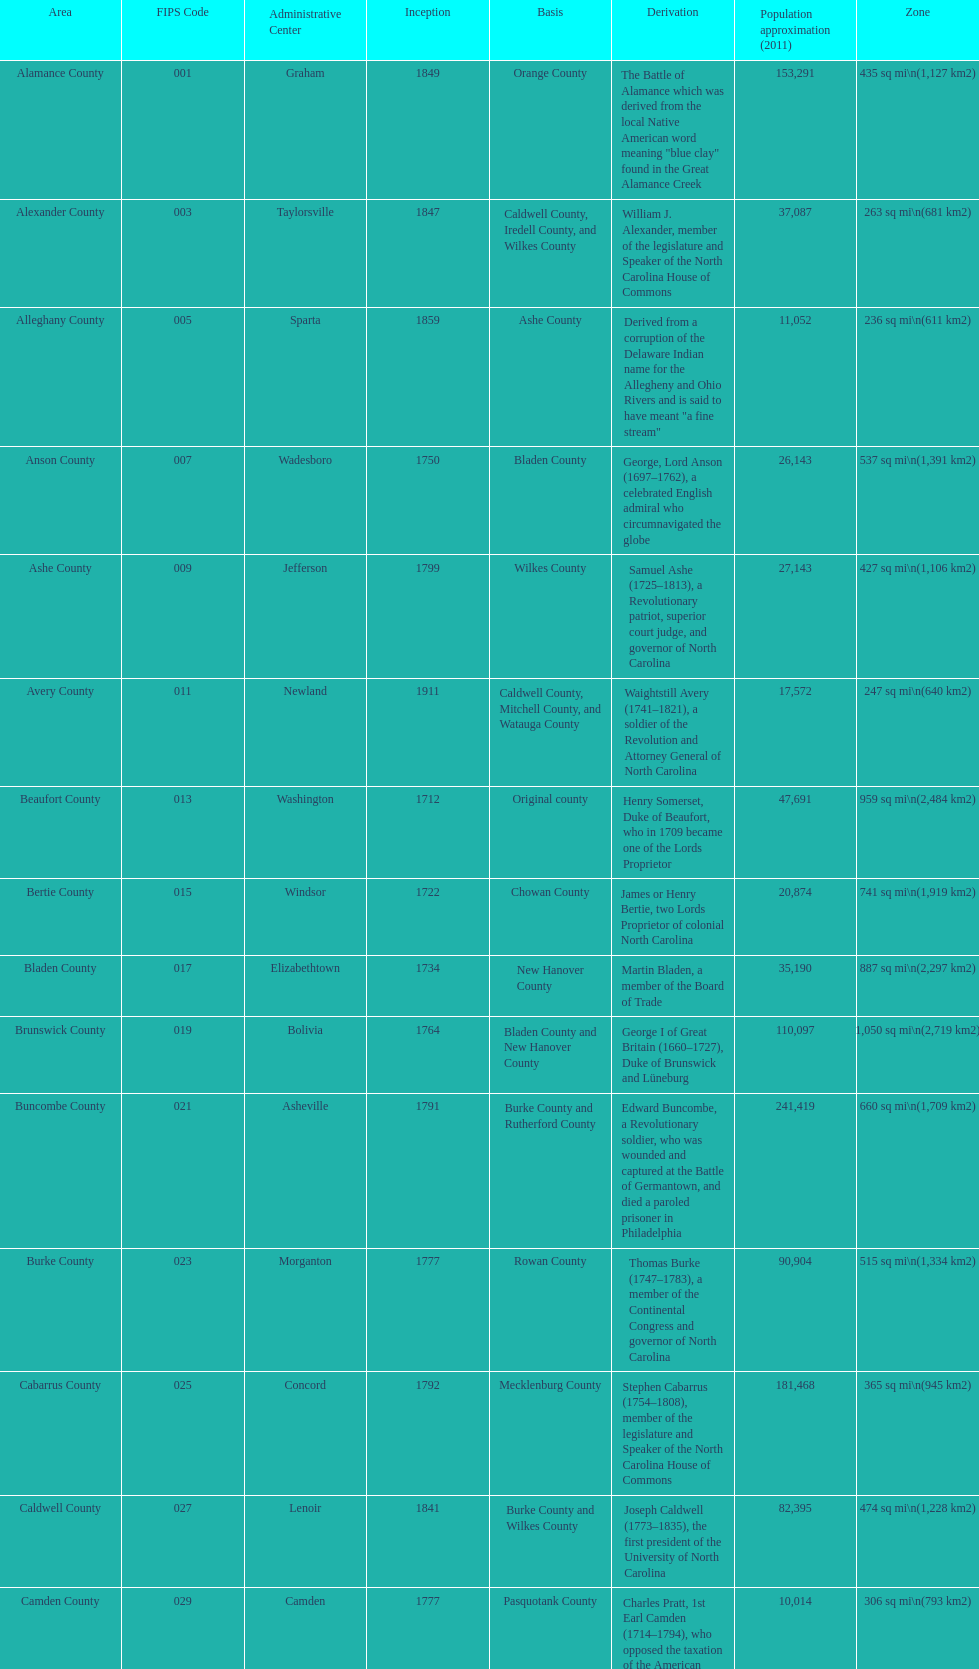What is the only county whose name comes from a battle? Alamance County. 